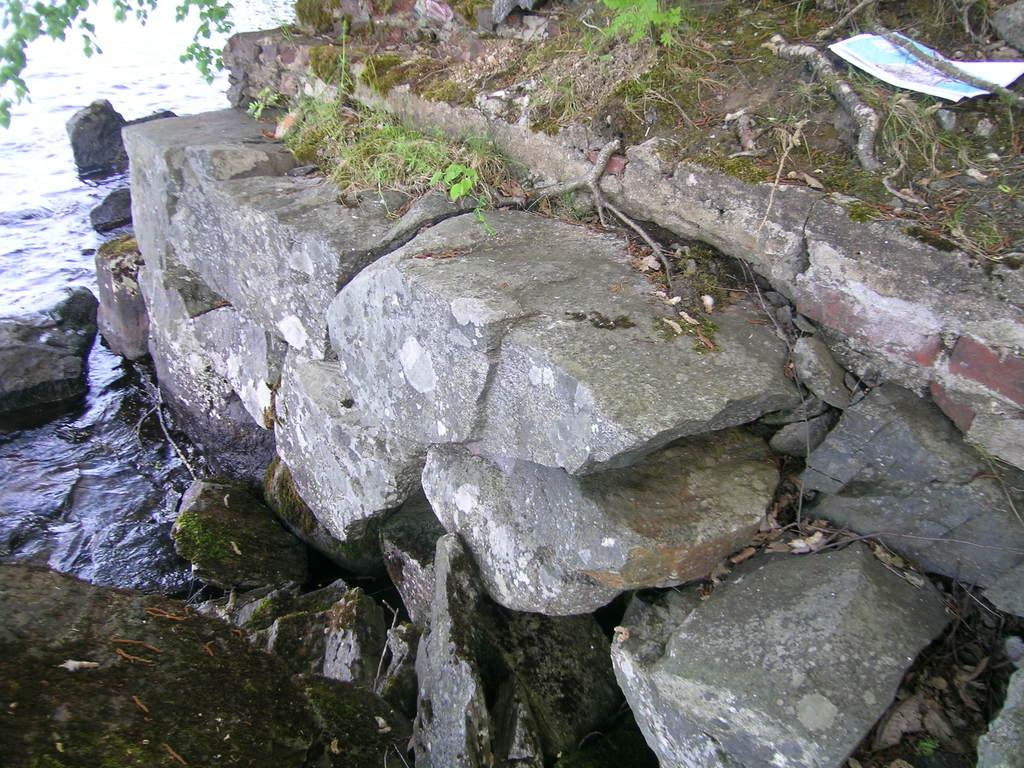What type of natural elements can be seen in the image? There are stones and grass visible in the image. What body of water is present in the image? There is a river with water visible in the image. What type of facial expression can be seen on the secretary in the image? There is no secretary present in the image; it features stones, grass, and a river. 